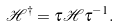Convert formula to latex. <formula><loc_0><loc_0><loc_500><loc_500>\mathcal { H } ^ { \dag } = \tau \mathcal { H } \tau ^ { - 1 } .</formula> 